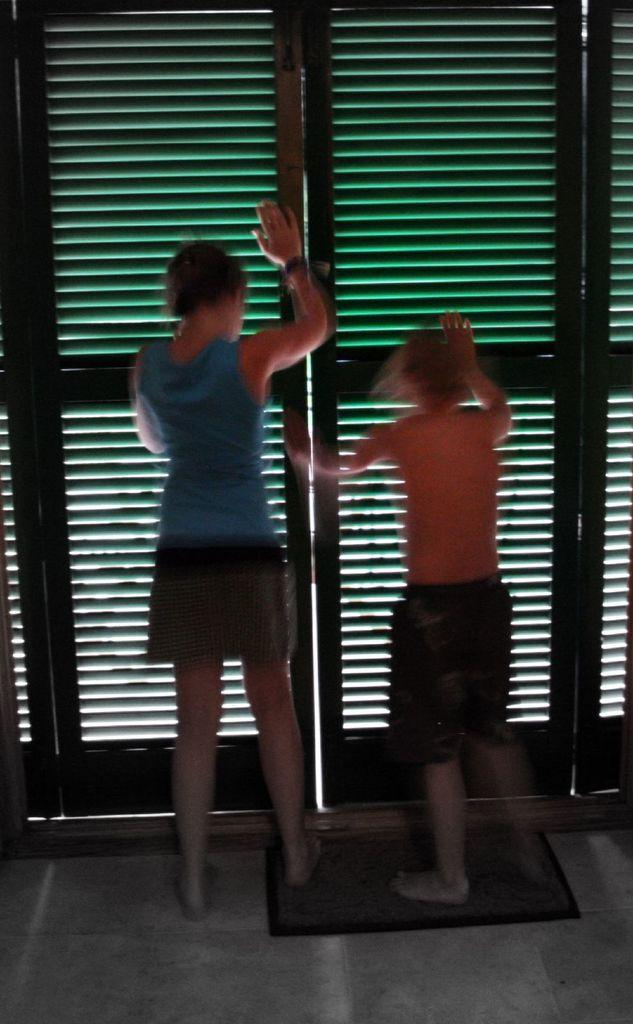How many people are in the image? There are two girls in the image. Where are the girls located in the image? The girls are standing on a door mat and on the floor. What are the girls doing in the image? The girls are pushing the doors. What might be the purpose of the door mat in the image? The door mat might be there to prevent dirt or water from being tracked into the building. Can you see the church in the background of the image? There is no church visible in the image. What type of ocean can be seen from the side of the image? There is no ocean present in the image. 